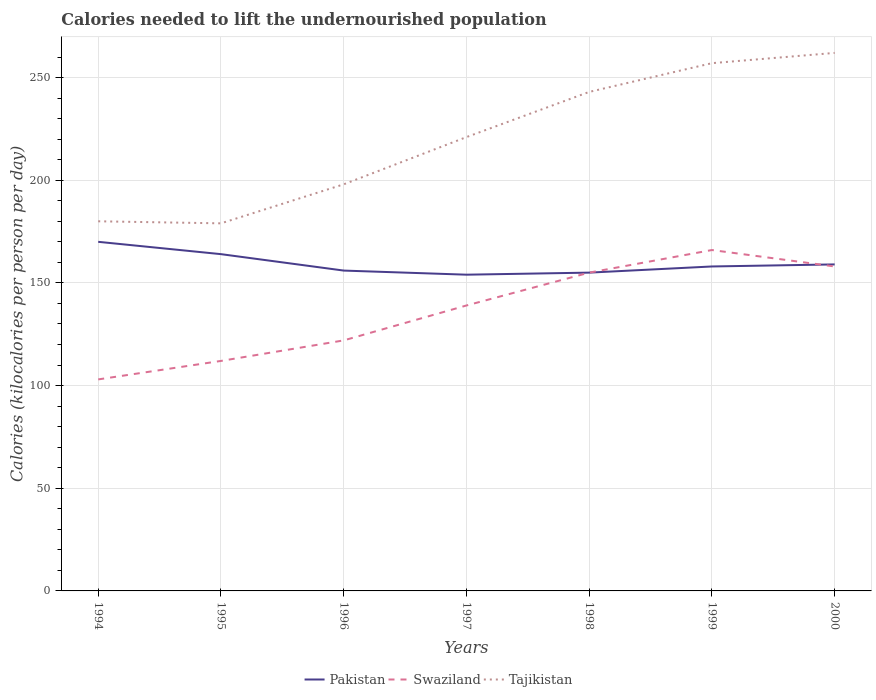How many different coloured lines are there?
Your answer should be very brief. 3. Is the number of lines equal to the number of legend labels?
Keep it short and to the point. Yes. Across all years, what is the maximum total calories needed to lift the undernourished population in Swaziland?
Provide a short and direct response. 103. What is the total total calories needed to lift the undernourished population in Pakistan in the graph?
Your answer should be very brief. -4. What is the difference between the highest and the second highest total calories needed to lift the undernourished population in Pakistan?
Provide a short and direct response. 16. How many lines are there?
Your answer should be compact. 3. How many years are there in the graph?
Offer a terse response. 7. What is the difference between two consecutive major ticks on the Y-axis?
Make the answer very short. 50. Does the graph contain any zero values?
Offer a very short reply. No. Where does the legend appear in the graph?
Your answer should be very brief. Bottom center. How are the legend labels stacked?
Your response must be concise. Horizontal. What is the title of the graph?
Your answer should be very brief. Calories needed to lift the undernourished population. Does "Yemen, Rep." appear as one of the legend labels in the graph?
Your answer should be very brief. No. What is the label or title of the Y-axis?
Keep it short and to the point. Calories (kilocalories per person per day). What is the Calories (kilocalories per person per day) of Pakistan in 1994?
Give a very brief answer. 170. What is the Calories (kilocalories per person per day) in Swaziland in 1994?
Provide a short and direct response. 103. What is the Calories (kilocalories per person per day) of Tajikistan in 1994?
Your answer should be compact. 180. What is the Calories (kilocalories per person per day) of Pakistan in 1995?
Your response must be concise. 164. What is the Calories (kilocalories per person per day) of Swaziland in 1995?
Provide a succinct answer. 112. What is the Calories (kilocalories per person per day) in Tajikistan in 1995?
Keep it short and to the point. 179. What is the Calories (kilocalories per person per day) of Pakistan in 1996?
Your response must be concise. 156. What is the Calories (kilocalories per person per day) of Swaziland in 1996?
Give a very brief answer. 122. What is the Calories (kilocalories per person per day) of Tajikistan in 1996?
Offer a very short reply. 198. What is the Calories (kilocalories per person per day) of Pakistan in 1997?
Offer a very short reply. 154. What is the Calories (kilocalories per person per day) in Swaziland in 1997?
Your response must be concise. 139. What is the Calories (kilocalories per person per day) in Tajikistan in 1997?
Your response must be concise. 221. What is the Calories (kilocalories per person per day) in Pakistan in 1998?
Your answer should be very brief. 155. What is the Calories (kilocalories per person per day) of Swaziland in 1998?
Keep it short and to the point. 155. What is the Calories (kilocalories per person per day) of Tajikistan in 1998?
Your answer should be very brief. 243. What is the Calories (kilocalories per person per day) in Pakistan in 1999?
Keep it short and to the point. 158. What is the Calories (kilocalories per person per day) in Swaziland in 1999?
Your answer should be very brief. 166. What is the Calories (kilocalories per person per day) in Tajikistan in 1999?
Your answer should be very brief. 257. What is the Calories (kilocalories per person per day) in Pakistan in 2000?
Your answer should be compact. 159. What is the Calories (kilocalories per person per day) in Swaziland in 2000?
Provide a succinct answer. 158. What is the Calories (kilocalories per person per day) in Tajikistan in 2000?
Provide a succinct answer. 262. Across all years, what is the maximum Calories (kilocalories per person per day) in Pakistan?
Keep it short and to the point. 170. Across all years, what is the maximum Calories (kilocalories per person per day) in Swaziland?
Give a very brief answer. 166. Across all years, what is the maximum Calories (kilocalories per person per day) in Tajikistan?
Your response must be concise. 262. Across all years, what is the minimum Calories (kilocalories per person per day) in Pakistan?
Give a very brief answer. 154. Across all years, what is the minimum Calories (kilocalories per person per day) in Swaziland?
Give a very brief answer. 103. Across all years, what is the minimum Calories (kilocalories per person per day) of Tajikistan?
Give a very brief answer. 179. What is the total Calories (kilocalories per person per day) of Pakistan in the graph?
Offer a very short reply. 1116. What is the total Calories (kilocalories per person per day) in Swaziland in the graph?
Your answer should be compact. 955. What is the total Calories (kilocalories per person per day) of Tajikistan in the graph?
Offer a very short reply. 1540. What is the difference between the Calories (kilocalories per person per day) of Swaziland in 1994 and that in 1995?
Keep it short and to the point. -9. What is the difference between the Calories (kilocalories per person per day) in Tajikistan in 1994 and that in 1995?
Make the answer very short. 1. What is the difference between the Calories (kilocalories per person per day) of Pakistan in 1994 and that in 1996?
Offer a very short reply. 14. What is the difference between the Calories (kilocalories per person per day) of Swaziland in 1994 and that in 1996?
Offer a very short reply. -19. What is the difference between the Calories (kilocalories per person per day) in Tajikistan in 1994 and that in 1996?
Keep it short and to the point. -18. What is the difference between the Calories (kilocalories per person per day) in Swaziland in 1994 and that in 1997?
Offer a very short reply. -36. What is the difference between the Calories (kilocalories per person per day) of Tajikistan in 1994 and that in 1997?
Provide a short and direct response. -41. What is the difference between the Calories (kilocalories per person per day) in Swaziland in 1994 and that in 1998?
Provide a succinct answer. -52. What is the difference between the Calories (kilocalories per person per day) of Tajikistan in 1994 and that in 1998?
Keep it short and to the point. -63. What is the difference between the Calories (kilocalories per person per day) of Pakistan in 1994 and that in 1999?
Ensure brevity in your answer.  12. What is the difference between the Calories (kilocalories per person per day) in Swaziland in 1994 and that in 1999?
Your answer should be very brief. -63. What is the difference between the Calories (kilocalories per person per day) of Tajikistan in 1994 and that in 1999?
Offer a very short reply. -77. What is the difference between the Calories (kilocalories per person per day) in Swaziland in 1994 and that in 2000?
Keep it short and to the point. -55. What is the difference between the Calories (kilocalories per person per day) in Tajikistan in 1994 and that in 2000?
Ensure brevity in your answer.  -82. What is the difference between the Calories (kilocalories per person per day) of Pakistan in 1995 and that in 1996?
Offer a terse response. 8. What is the difference between the Calories (kilocalories per person per day) in Swaziland in 1995 and that in 1996?
Make the answer very short. -10. What is the difference between the Calories (kilocalories per person per day) of Tajikistan in 1995 and that in 1996?
Keep it short and to the point. -19. What is the difference between the Calories (kilocalories per person per day) in Pakistan in 1995 and that in 1997?
Offer a terse response. 10. What is the difference between the Calories (kilocalories per person per day) of Tajikistan in 1995 and that in 1997?
Give a very brief answer. -42. What is the difference between the Calories (kilocalories per person per day) in Pakistan in 1995 and that in 1998?
Ensure brevity in your answer.  9. What is the difference between the Calories (kilocalories per person per day) of Swaziland in 1995 and that in 1998?
Offer a terse response. -43. What is the difference between the Calories (kilocalories per person per day) in Tajikistan in 1995 and that in 1998?
Give a very brief answer. -64. What is the difference between the Calories (kilocalories per person per day) in Swaziland in 1995 and that in 1999?
Your answer should be compact. -54. What is the difference between the Calories (kilocalories per person per day) of Tajikistan in 1995 and that in 1999?
Give a very brief answer. -78. What is the difference between the Calories (kilocalories per person per day) in Swaziland in 1995 and that in 2000?
Make the answer very short. -46. What is the difference between the Calories (kilocalories per person per day) of Tajikistan in 1995 and that in 2000?
Make the answer very short. -83. What is the difference between the Calories (kilocalories per person per day) of Swaziland in 1996 and that in 1997?
Offer a terse response. -17. What is the difference between the Calories (kilocalories per person per day) of Swaziland in 1996 and that in 1998?
Your response must be concise. -33. What is the difference between the Calories (kilocalories per person per day) in Tajikistan in 1996 and that in 1998?
Your response must be concise. -45. What is the difference between the Calories (kilocalories per person per day) of Pakistan in 1996 and that in 1999?
Your response must be concise. -2. What is the difference between the Calories (kilocalories per person per day) of Swaziland in 1996 and that in 1999?
Your response must be concise. -44. What is the difference between the Calories (kilocalories per person per day) of Tajikistan in 1996 and that in 1999?
Give a very brief answer. -59. What is the difference between the Calories (kilocalories per person per day) in Swaziland in 1996 and that in 2000?
Ensure brevity in your answer.  -36. What is the difference between the Calories (kilocalories per person per day) in Tajikistan in 1996 and that in 2000?
Your answer should be very brief. -64. What is the difference between the Calories (kilocalories per person per day) in Pakistan in 1997 and that in 1998?
Your answer should be compact. -1. What is the difference between the Calories (kilocalories per person per day) in Tajikistan in 1997 and that in 1999?
Provide a succinct answer. -36. What is the difference between the Calories (kilocalories per person per day) in Swaziland in 1997 and that in 2000?
Provide a short and direct response. -19. What is the difference between the Calories (kilocalories per person per day) of Tajikistan in 1997 and that in 2000?
Provide a succinct answer. -41. What is the difference between the Calories (kilocalories per person per day) of Pakistan in 1998 and that in 1999?
Provide a short and direct response. -3. What is the difference between the Calories (kilocalories per person per day) of Swaziland in 1998 and that in 1999?
Make the answer very short. -11. What is the difference between the Calories (kilocalories per person per day) of Tajikistan in 1998 and that in 1999?
Provide a succinct answer. -14. What is the difference between the Calories (kilocalories per person per day) of Pakistan in 1998 and that in 2000?
Your answer should be compact. -4. What is the difference between the Calories (kilocalories per person per day) of Swaziland in 1998 and that in 2000?
Give a very brief answer. -3. What is the difference between the Calories (kilocalories per person per day) of Tajikistan in 1998 and that in 2000?
Make the answer very short. -19. What is the difference between the Calories (kilocalories per person per day) in Pakistan in 1999 and that in 2000?
Your answer should be compact. -1. What is the difference between the Calories (kilocalories per person per day) in Swaziland in 1999 and that in 2000?
Your response must be concise. 8. What is the difference between the Calories (kilocalories per person per day) in Pakistan in 1994 and the Calories (kilocalories per person per day) in Swaziland in 1995?
Provide a succinct answer. 58. What is the difference between the Calories (kilocalories per person per day) of Swaziland in 1994 and the Calories (kilocalories per person per day) of Tajikistan in 1995?
Make the answer very short. -76. What is the difference between the Calories (kilocalories per person per day) of Pakistan in 1994 and the Calories (kilocalories per person per day) of Swaziland in 1996?
Give a very brief answer. 48. What is the difference between the Calories (kilocalories per person per day) in Swaziland in 1994 and the Calories (kilocalories per person per day) in Tajikistan in 1996?
Your response must be concise. -95. What is the difference between the Calories (kilocalories per person per day) in Pakistan in 1994 and the Calories (kilocalories per person per day) in Tajikistan in 1997?
Provide a succinct answer. -51. What is the difference between the Calories (kilocalories per person per day) in Swaziland in 1994 and the Calories (kilocalories per person per day) in Tajikistan in 1997?
Give a very brief answer. -118. What is the difference between the Calories (kilocalories per person per day) of Pakistan in 1994 and the Calories (kilocalories per person per day) of Swaziland in 1998?
Your response must be concise. 15. What is the difference between the Calories (kilocalories per person per day) of Pakistan in 1994 and the Calories (kilocalories per person per day) of Tajikistan in 1998?
Offer a very short reply. -73. What is the difference between the Calories (kilocalories per person per day) in Swaziland in 1994 and the Calories (kilocalories per person per day) in Tajikistan in 1998?
Make the answer very short. -140. What is the difference between the Calories (kilocalories per person per day) of Pakistan in 1994 and the Calories (kilocalories per person per day) of Tajikistan in 1999?
Keep it short and to the point. -87. What is the difference between the Calories (kilocalories per person per day) in Swaziland in 1994 and the Calories (kilocalories per person per day) in Tajikistan in 1999?
Offer a terse response. -154. What is the difference between the Calories (kilocalories per person per day) of Pakistan in 1994 and the Calories (kilocalories per person per day) of Tajikistan in 2000?
Provide a succinct answer. -92. What is the difference between the Calories (kilocalories per person per day) in Swaziland in 1994 and the Calories (kilocalories per person per day) in Tajikistan in 2000?
Provide a short and direct response. -159. What is the difference between the Calories (kilocalories per person per day) of Pakistan in 1995 and the Calories (kilocalories per person per day) of Swaziland in 1996?
Ensure brevity in your answer.  42. What is the difference between the Calories (kilocalories per person per day) of Pakistan in 1995 and the Calories (kilocalories per person per day) of Tajikistan in 1996?
Give a very brief answer. -34. What is the difference between the Calories (kilocalories per person per day) in Swaziland in 1995 and the Calories (kilocalories per person per day) in Tajikistan in 1996?
Make the answer very short. -86. What is the difference between the Calories (kilocalories per person per day) in Pakistan in 1995 and the Calories (kilocalories per person per day) in Tajikistan in 1997?
Your response must be concise. -57. What is the difference between the Calories (kilocalories per person per day) in Swaziland in 1995 and the Calories (kilocalories per person per day) in Tajikistan in 1997?
Keep it short and to the point. -109. What is the difference between the Calories (kilocalories per person per day) of Pakistan in 1995 and the Calories (kilocalories per person per day) of Tajikistan in 1998?
Your response must be concise. -79. What is the difference between the Calories (kilocalories per person per day) of Swaziland in 1995 and the Calories (kilocalories per person per day) of Tajikistan in 1998?
Provide a short and direct response. -131. What is the difference between the Calories (kilocalories per person per day) of Pakistan in 1995 and the Calories (kilocalories per person per day) of Swaziland in 1999?
Give a very brief answer. -2. What is the difference between the Calories (kilocalories per person per day) in Pakistan in 1995 and the Calories (kilocalories per person per day) in Tajikistan in 1999?
Provide a short and direct response. -93. What is the difference between the Calories (kilocalories per person per day) in Swaziland in 1995 and the Calories (kilocalories per person per day) in Tajikistan in 1999?
Offer a terse response. -145. What is the difference between the Calories (kilocalories per person per day) of Pakistan in 1995 and the Calories (kilocalories per person per day) of Swaziland in 2000?
Offer a very short reply. 6. What is the difference between the Calories (kilocalories per person per day) in Pakistan in 1995 and the Calories (kilocalories per person per day) in Tajikistan in 2000?
Make the answer very short. -98. What is the difference between the Calories (kilocalories per person per day) in Swaziland in 1995 and the Calories (kilocalories per person per day) in Tajikistan in 2000?
Your answer should be compact. -150. What is the difference between the Calories (kilocalories per person per day) of Pakistan in 1996 and the Calories (kilocalories per person per day) of Swaziland in 1997?
Give a very brief answer. 17. What is the difference between the Calories (kilocalories per person per day) in Pakistan in 1996 and the Calories (kilocalories per person per day) in Tajikistan in 1997?
Keep it short and to the point. -65. What is the difference between the Calories (kilocalories per person per day) in Swaziland in 1996 and the Calories (kilocalories per person per day) in Tajikistan in 1997?
Your answer should be very brief. -99. What is the difference between the Calories (kilocalories per person per day) in Pakistan in 1996 and the Calories (kilocalories per person per day) in Swaziland in 1998?
Ensure brevity in your answer.  1. What is the difference between the Calories (kilocalories per person per day) in Pakistan in 1996 and the Calories (kilocalories per person per day) in Tajikistan in 1998?
Your response must be concise. -87. What is the difference between the Calories (kilocalories per person per day) in Swaziland in 1996 and the Calories (kilocalories per person per day) in Tajikistan in 1998?
Provide a succinct answer. -121. What is the difference between the Calories (kilocalories per person per day) in Pakistan in 1996 and the Calories (kilocalories per person per day) in Swaziland in 1999?
Keep it short and to the point. -10. What is the difference between the Calories (kilocalories per person per day) in Pakistan in 1996 and the Calories (kilocalories per person per day) in Tajikistan in 1999?
Your answer should be very brief. -101. What is the difference between the Calories (kilocalories per person per day) of Swaziland in 1996 and the Calories (kilocalories per person per day) of Tajikistan in 1999?
Your answer should be very brief. -135. What is the difference between the Calories (kilocalories per person per day) of Pakistan in 1996 and the Calories (kilocalories per person per day) of Swaziland in 2000?
Your answer should be compact. -2. What is the difference between the Calories (kilocalories per person per day) of Pakistan in 1996 and the Calories (kilocalories per person per day) of Tajikistan in 2000?
Keep it short and to the point. -106. What is the difference between the Calories (kilocalories per person per day) of Swaziland in 1996 and the Calories (kilocalories per person per day) of Tajikistan in 2000?
Your response must be concise. -140. What is the difference between the Calories (kilocalories per person per day) of Pakistan in 1997 and the Calories (kilocalories per person per day) of Swaziland in 1998?
Your answer should be very brief. -1. What is the difference between the Calories (kilocalories per person per day) of Pakistan in 1997 and the Calories (kilocalories per person per day) of Tajikistan in 1998?
Offer a terse response. -89. What is the difference between the Calories (kilocalories per person per day) in Swaziland in 1997 and the Calories (kilocalories per person per day) in Tajikistan in 1998?
Offer a terse response. -104. What is the difference between the Calories (kilocalories per person per day) in Pakistan in 1997 and the Calories (kilocalories per person per day) in Swaziland in 1999?
Provide a short and direct response. -12. What is the difference between the Calories (kilocalories per person per day) in Pakistan in 1997 and the Calories (kilocalories per person per day) in Tajikistan in 1999?
Offer a terse response. -103. What is the difference between the Calories (kilocalories per person per day) of Swaziland in 1997 and the Calories (kilocalories per person per day) of Tajikistan in 1999?
Offer a very short reply. -118. What is the difference between the Calories (kilocalories per person per day) in Pakistan in 1997 and the Calories (kilocalories per person per day) in Tajikistan in 2000?
Keep it short and to the point. -108. What is the difference between the Calories (kilocalories per person per day) of Swaziland in 1997 and the Calories (kilocalories per person per day) of Tajikistan in 2000?
Give a very brief answer. -123. What is the difference between the Calories (kilocalories per person per day) in Pakistan in 1998 and the Calories (kilocalories per person per day) in Swaziland in 1999?
Your answer should be very brief. -11. What is the difference between the Calories (kilocalories per person per day) of Pakistan in 1998 and the Calories (kilocalories per person per day) of Tajikistan in 1999?
Your answer should be compact. -102. What is the difference between the Calories (kilocalories per person per day) in Swaziland in 1998 and the Calories (kilocalories per person per day) in Tajikistan in 1999?
Provide a succinct answer. -102. What is the difference between the Calories (kilocalories per person per day) in Pakistan in 1998 and the Calories (kilocalories per person per day) in Swaziland in 2000?
Ensure brevity in your answer.  -3. What is the difference between the Calories (kilocalories per person per day) of Pakistan in 1998 and the Calories (kilocalories per person per day) of Tajikistan in 2000?
Offer a terse response. -107. What is the difference between the Calories (kilocalories per person per day) of Swaziland in 1998 and the Calories (kilocalories per person per day) of Tajikistan in 2000?
Your response must be concise. -107. What is the difference between the Calories (kilocalories per person per day) in Pakistan in 1999 and the Calories (kilocalories per person per day) in Swaziland in 2000?
Keep it short and to the point. 0. What is the difference between the Calories (kilocalories per person per day) of Pakistan in 1999 and the Calories (kilocalories per person per day) of Tajikistan in 2000?
Provide a succinct answer. -104. What is the difference between the Calories (kilocalories per person per day) of Swaziland in 1999 and the Calories (kilocalories per person per day) of Tajikistan in 2000?
Offer a very short reply. -96. What is the average Calories (kilocalories per person per day) in Pakistan per year?
Your answer should be very brief. 159.43. What is the average Calories (kilocalories per person per day) of Swaziland per year?
Keep it short and to the point. 136.43. What is the average Calories (kilocalories per person per day) in Tajikistan per year?
Offer a very short reply. 220. In the year 1994, what is the difference between the Calories (kilocalories per person per day) in Pakistan and Calories (kilocalories per person per day) in Swaziland?
Give a very brief answer. 67. In the year 1994, what is the difference between the Calories (kilocalories per person per day) of Pakistan and Calories (kilocalories per person per day) of Tajikistan?
Offer a terse response. -10. In the year 1994, what is the difference between the Calories (kilocalories per person per day) in Swaziland and Calories (kilocalories per person per day) in Tajikistan?
Offer a very short reply. -77. In the year 1995, what is the difference between the Calories (kilocalories per person per day) in Pakistan and Calories (kilocalories per person per day) in Tajikistan?
Provide a succinct answer. -15. In the year 1995, what is the difference between the Calories (kilocalories per person per day) in Swaziland and Calories (kilocalories per person per day) in Tajikistan?
Make the answer very short. -67. In the year 1996, what is the difference between the Calories (kilocalories per person per day) in Pakistan and Calories (kilocalories per person per day) in Tajikistan?
Provide a short and direct response. -42. In the year 1996, what is the difference between the Calories (kilocalories per person per day) of Swaziland and Calories (kilocalories per person per day) of Tajikistan?
Your response must be concise. -76. In the year 1997, what is the difference between the Calories (kilocalories per person per day) in Pakistan and Calories (kilocalories per person per day) in Tajikistan?
Ensure brevity in your answer.  -67. In the year 1997, what is the difference between the Calories (kilocalories per person per day) in Swaziland and Calories (kilocalories per person per day) in Tajikistan?
Give a very brief answer. -82. In the year 1998, what is the difference between the Calories (kilocalories per person per day) in Pakistan and Calories (kilocalories per person per day) in Swaziland?
Your response must be concise. 0. In the year 1998, what is the difference between the Calories (kilocalories per person per day) in Pakistan and Calories (kilocalories per person per day) in Tajikistan?
Keep it short and to the point. -88. In the year 1998, what is the difference between the Calories (kilocalories per person per day) of Swaziland and Calories (kilocalories per person per day) of Tajikistan?
Keep it short and to the point. -88. In the year 1999, what is the difference between the Calories (kilocalories per person per day) in Pakistan and Calories (kilocalories per person per day) in Swaziland?
Offer a very short reply. -8. In the year 1999, what is the difference between the Calories (kilocalories per person per day) of Pakistan and Calories (kilocalories per person per day) of Tajikistan?
Your response must be concise. -99. In the year 1999, what is the difference between the Calories (kilocalories per person per day) in Swaziland and Calories (kilocalories per person per day) in Tajikistan?
Offer a very short reply. -91. In the year 2000, what is the difference between the Calories (kilocalories per person per day) in Pakistan and Calories (kilocalories per person per day) in Tajikistan?
Your answer should be compact. -103. In the year 2000, what is the difference between the Calories (kilocalories per person per day) in Swaziland and Calories (kilocalories per person per day) in Tajikistan?
Make the answer very short. -104. What is the ratio of the Calories (kilocalories per person per day) of Pakistan in 1994 to that in 1995?
Your answer should be very brief. 1.04. What is the ratio of the Calories (kilocalories per person per day) of Swaziland in 1994 to that in 1995?
Keep it short and to the point. 0.92. What is the ratio of the Calories (kilocalories per person per day) in Tajikistan in 1994 to that in 1995?
Provide a short and direct response. 1.01. What is the ratio of the Calories (kilocalories per person per day) of Pakistan in 1994 to that in 1996?
Offer a very short reply. 1.09. What is the ratio of the Calories (kilocalories per person per day) of Swaziland in 1994 to that in 1996?
Offer a terse response. 0.84. What is the ratio of the Calories (kilocalories per person per day) in Tajikistan in 1994 to that in 1996?
Ensure brevity in your answer.  0.91. What is the ratio of the Calories (kilocalories per person per day) of Pakistan in 1994 to that in 1997?
Provide a succinct answer. 1.1. What is the ratio of the Calories (kilocalories per person per day) in Swaziland in 1994 to that in 1997?
Your answer should be very brief. 0.74. What is the ratio of the Calories (kilocalories per person per day) in Tajikistan in 1994 to that in 1997?
Make the answer very short. 0.81. What is the ratio of the Calories (kilocalories per person per day) of Pakistan in 1994 to that in 1998?
Your response must be concise. 1.1. What is the ratio of the Calories (kilocalories per person per day) in Swaziland in 1994 to that in 1998?
Make the answer very short. 0.66. What is the ratio of the Calories (kilocalories per person per day) in Tajikistan in 1994 to that in 1998?
Offer a very short reply. 0.74. What is the ratio of the Calories (kilocalories per person per day) of Pakistan in 1994 to that in 1999?
Offer a very short reply. 1.08. What is the ratio of the Calories (kilocalories per person per day) in Swaziland in 1994 to that in 1999?
Your response must be concise. 0.62. What is the ratio of the Calories (kilocalories per person per day) in Tajikistan in 1994 to that in 1999?
Keep it short and to the point. 0.7. What is the ratio of the Calories (kilocalories per person per day) in Pakistan in 1994 to that in 2000?
Give a very brief answer. 1.07. What is the ratio of the Calories (kilocalories per person per day) of Swaziland in 1994 to that in 2000?
Keep it short and to the point. 0.65. What is the ratio of the Calories (kilocalories per person per day) of Tajikistan in 1994 to that in 2000?
Your response must be concise. 0.69. What is the ratio of the Calories (kilocalories per person per day) in Pakistan in 1995 to that in 1996?
Offer a terse response. 1.05. What is the ratio of the Calories (kilocalories per person per day) in Swaziland in 1995 to that in 1996?
Your answer should be very brief. 0.92. What is the ratio of the Calories (kilocalories per person per day) of Tajikistan in 1995 to that in 1996?
Give a very brief answer. 0.9. What is the ratio of the Calories (kilocalories per person per day) of Pakistan in 1995 to that in 1997?
Offer a very short reply. 1.06. What is the ratio of the Calories (kilocalories per person per day) of Swaziland in 1995 to that in 1997?
Your answer should be very brief. 0.81. What is the ratio of the Calories (kilocalories per person per day) in Tajikistan in 1995 to that in 1997?
Keep it short and to the point. 0.81. What is the ratio of the Calories (kilocalories per person per day) in Pakistan in 1995 to that in 1998?
Make the answer very short. 1.06. What is the ratio of the Calories (kilocalories per person per day) of Swaziland in 1995 to that in 1998?
Provide a short and direct response. 0.72. What is the ratio of the Calories (kilocalories per person per day) in Tajikistan in 1995 to that in 1998?
Ensure brevity in your answer.  0.74. What is the ratio of the Calories (kilocalories per person per day) in Pakistan in 1995 to that in 1999?
Provide a short and direct response. 1.04. What is the ratio of the Calories (kilocalories per person per day) in Swaziland in 1995 to that in 1999?
Keep it short and to the point. 0.67. What is the ratio of the Calories (kilocalories per person per day) of Tajikistan in 1995 to that in 1999?
Give a very brief answer. 0.7. What is the ratio of the Calories (kilocalories per person per day) of Pakistan in 1995 to that in 2000?
Make the answer very short. 1.03. What is the ratio of the Calories (kilocalories per person per day) of Swaziland in 1995 to that in 2000?
Offer a very short reply. 0.71. What is the ratio of the Calories (kilocalories per person per day) of Tajikistan in 1995 to that in 2000?
Your answer should be very brief. 0.68. What is the ratio of the Calories (kilocalories per person per day) in Swaziland in 1996 to that in 1997?
Keep it short and to the point. 0.88. What is the ratio of the Calories (kilocalories per person per day) of Tajikistan in 1996 to that in 1997?
Offer a terse response. 0.9. What is the ratio of the Calories (kilocalories per person per day) in Swaziland in 1996 to that in 1998?
Offer a terse response. 0.79. What is the ratio of the Calories (kilocalories per person per day) of Tajikistan in 1996 to that in 1998?
Make the answer very short. 0.81. What is the ratio of the Calories (kilocalories per person per day) in Pakistan in 1996 to that in 1999?
Your answer should be very brief. 0.99. What is the ratio of the Calories (kilocalories per person per day) of Swaziland in 1996 to that in 1999?
Your response must be concise. 0.73. What is the ratio of the Calories (kilocalories per person per day) in Tajikistan in 1996 to that in 1999?
Your answer should be very brief. 0.77. What is the ratio of the Calories (kilocalories per person per day) of Pakistan in 1996 to that in 2000?
Your answer should be very brief. 0.98. What is the ratio of the Calories (kilocalories per person per day) of Swaziland in 1996 to that in 2000?
Your response must be concise. 0.77. What is the ratio of the Calories (kilocalories per person per day) in Tajikistan in 1996 to that in 2000?
Make the answer very short. 0.76. What is the ratio of the Calories (kilocalories per person per day) in Pakistan in 1997 to that in 1998?
Offer a very short reply. 0.99. What is the ratio of the Calories (kilocalories per person per day) of Swaziland in 1997 to that in 1998?
Provide a short and direct response. 0.9. What is the ratio of the Calories (kilocalories per person per day) in Tajikistan in 1997 to that in 1998?
Keep it short and to the point. 0.91. What is the ratio of the Calories (kilocalories per person per day) in Pakistan in 1997 to that in 1999?
Provide a short and direct response. 0.97. What is the ratio of the Calories (kilocalories per person per day) in Swaziland in 1997 to that in 1999?
Give a very brief answer. 0.84. What is the ratio of the Calories (kilocalories per person per day) in Tajikistan in 1997 to that in 1999?
Give a very brief answer. 0.86. What is the ratio of the Calories (kilocalories per person per day) of Pakistan in 1997 to that in 2000?
Your response must be concise. 0.97. What is the ratio of the Calories (kilocalories per person per day) of Swaziland in 1997 to that in 2000?
Give a very brief answer. 0.88. What is the ratio of the Calories (kilocalories per person per day) of Tajikistan in 1997 to that in 2000?
Keep it short and to the point. 0.84. What is the ratio of the Calories (kilocalories per person per day) in Swaziland in 1998 to that in 1999?
Offer a very short reply. 0.93. What is the ratio of the Calories (kilocalories per person per day) in Tajikistan in 1998 to that in 1999?
Offer a very short reply. 0.95. What is the ratio of the Calories (kilocalories per person per day) in Pakistan in 1998 to that in 2000?
Your answer should be compact. 0.97. What is the ratio of the Calories (kilocalories per person per day) in Tajikistan in 1998 to that in 2000?
Keep it short and to the point. 0.93. What is the ratio of the Calories (kilocalories per person per day) of Swaziland in 1999 to that in 2000?
Offer a terse response. 1.05. What is the ratio of the Calories (kilocalories per person per day) in Tajikistan in 1999 to that in 2000?
Your response must be concise. 0.98. What is the difference between the highest and the second highest Calories (kilocalories per person per day) of Swaziland?
Your answer should be compact. 8. What is the difference between the highest and the lowest Calories (kilocalories per person per day) of Pakistan?
Provide a short and direct response. 16. What is the difference between the highest and the lowest Calories (kilocalories per person per day) in Swaziland?
Your answer should be very brief. 63. What is the difference between the highest and the lowest Calories (kilocalories per person per day) in Tajikistan?
Provide a short and direct response. 83. 